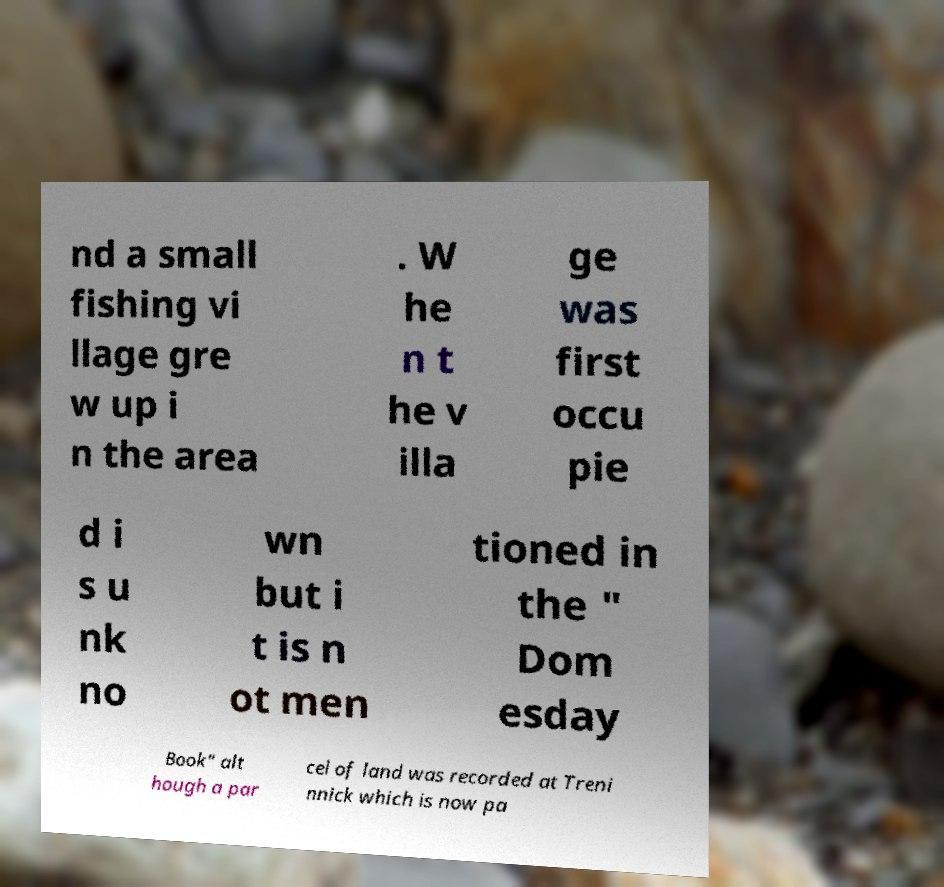Can you accurately transcribe the text from the provided image for me? nd a small fishing vi llage gre w up i n the area . W he n t he v illa ge was first occu pie d i s u nk no wn but i t is n ot men tioned in the " Dom esday Book" alt hough a par cel of land was recorded at Treni nnick which is now pa 